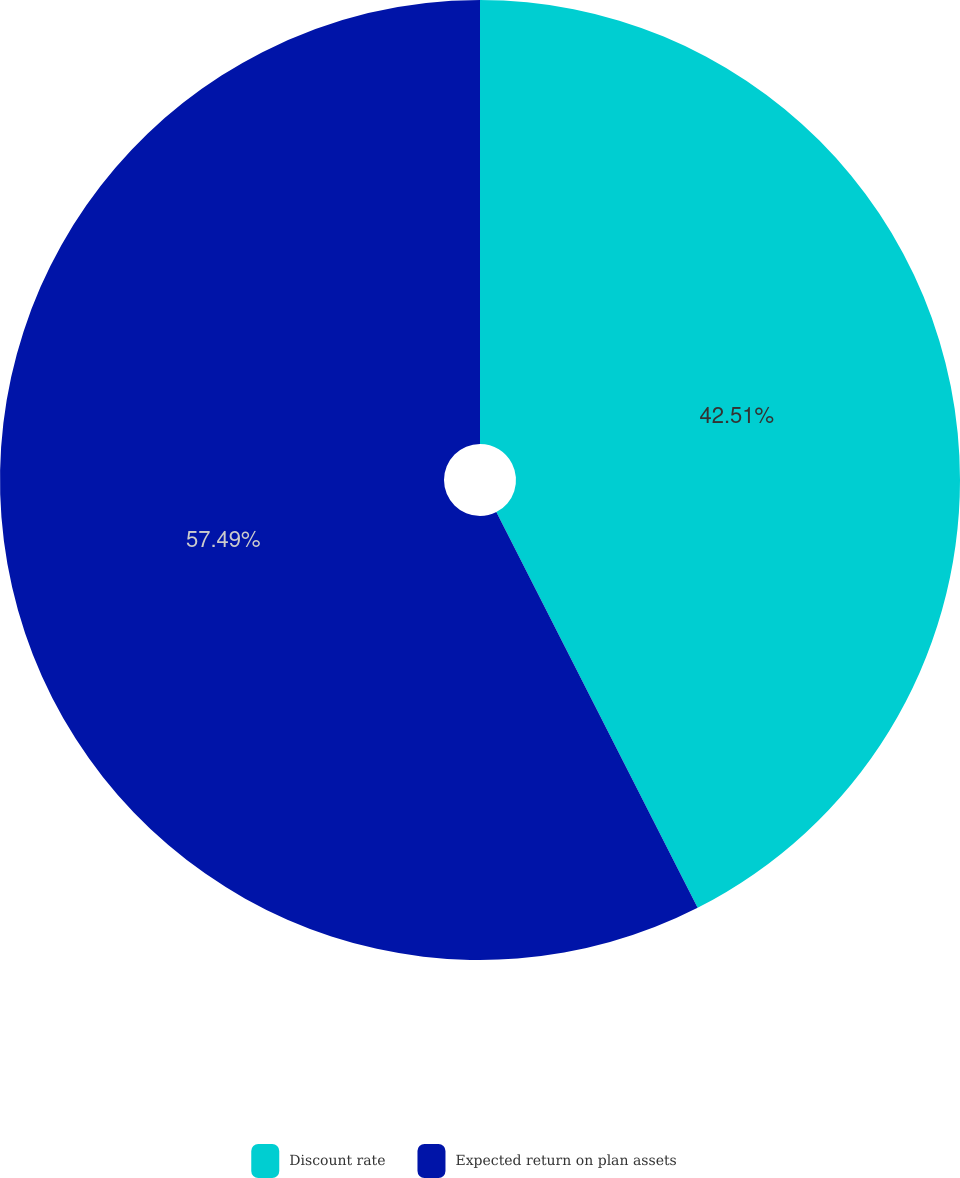Convert chart to OTSL. <chart><loc_0><loc_0><loc_500><loc_500><pie_chart><fcel>Discount rate<fcel>Expected return on plan assets<nl><fcel>42.51%<fcel>57.49%<nl></chart> 